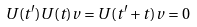Convert formula to latex. <formula><loc_0><loc_0><loc_500><loc_500>U ( t ^ { \prime } ) U ( t ) v = U ( t ^ { \prime } + t ) v = 0</formula> 